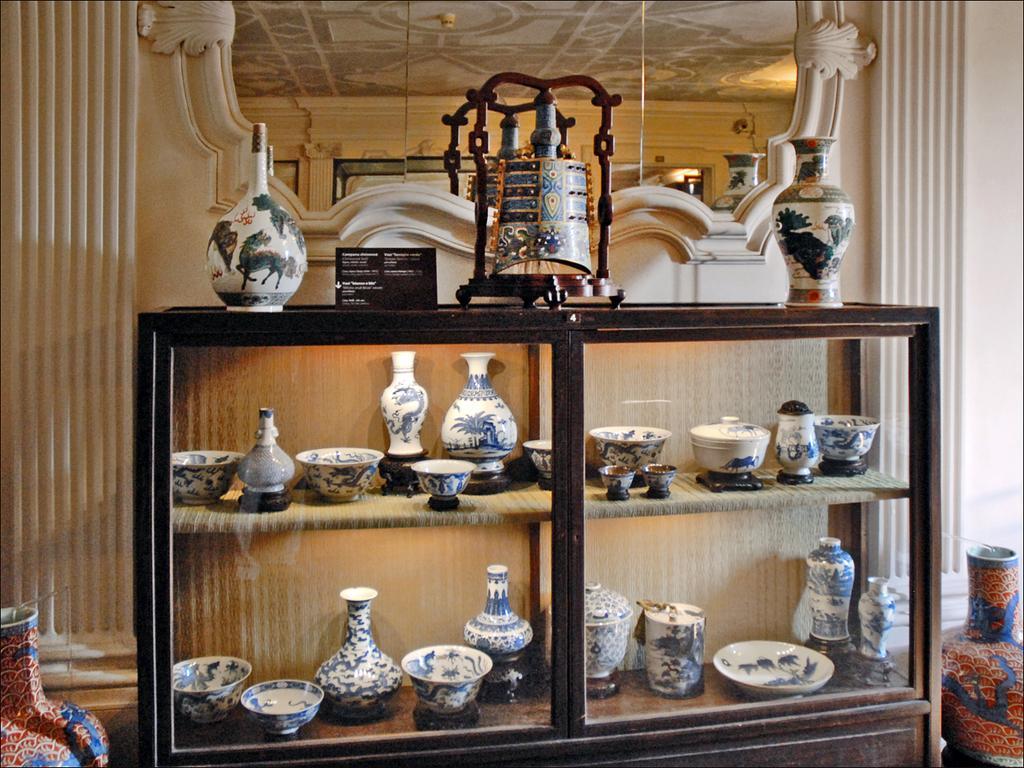How would you summarize this image in a sentence or two? In the center of the image we can see a cupboard. On cupboard we can see a vessels, containers are there. On the cupboard a board is there. On the left and right side of the image we can see a pots are present. At the top of the image a mirror is there. In the background of the image a wall is present. 